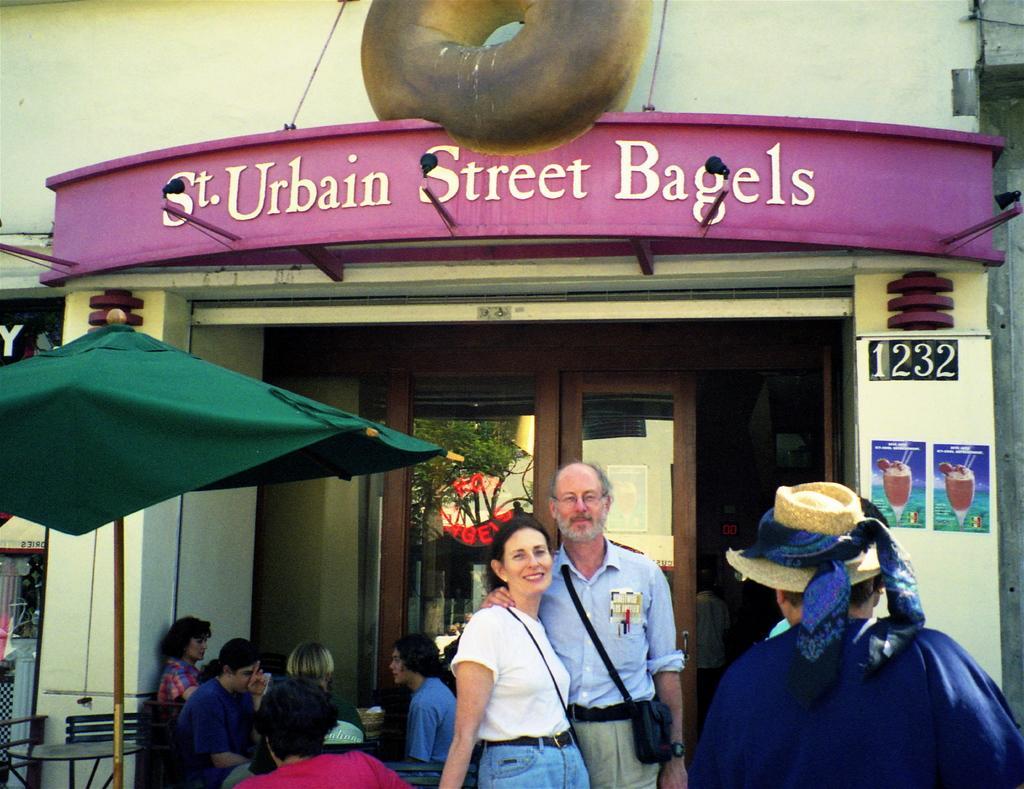In one or two sentences, can you explain what this image depicts? In the given image I can see a people, plant, board with text, chair and table. 